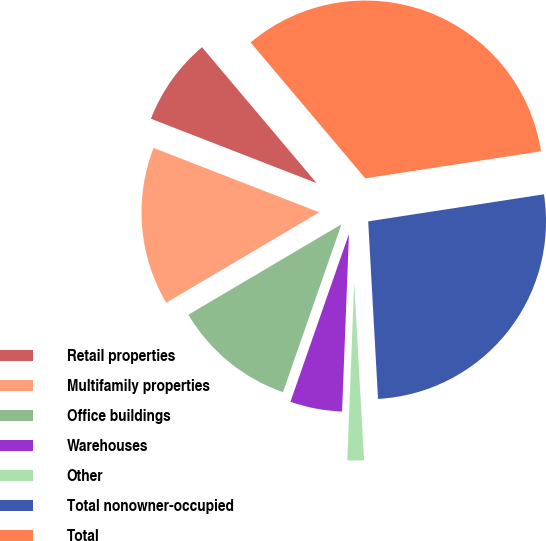<chart> <loc_0><loc_0><loc_500><loc_500><pie_chart><fcel>Retail properties<fcel>Multifamily properties<fcel>Office buildings<fcel>Warehouses<fcel>Other<fcel>Total nonowner-occupied<fcel>Total<nl><fcel>7.95%<fcel>14.39%<fcel>11.17%<fcel>4.72%<fcel>1.5%<fcel>26.55%<fcel>33.72%<nl></chart> 